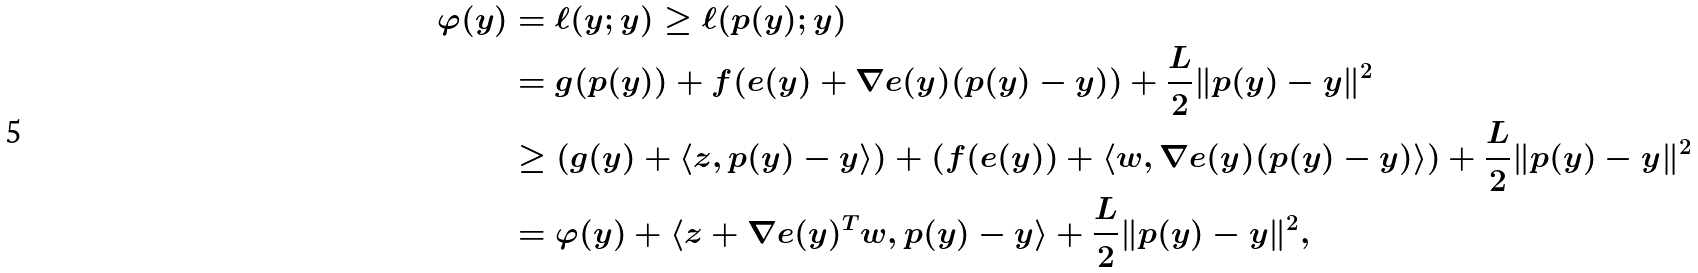Convert formula to latex. <formula><loc_0><loc_0><loc_500><loc_500>\varphi ( y ) & = \ell ( y ; y ) \geq \ell ( p ( y ) ; y ) \\ & = g ( p ( y ) ) + f ( e ( y ) + \nabla e ( y ) ( p ( y ) - y ) ) + \frac { L } { 2 } \| p ( y ) - y \| ^ { 2 } \\ & \geq ( g ( y ) + \langle z , p ( y ) - y \rangle ) + ( f ( e ( y ) ) + \langle w , \nabla e ( y ) ( p ( y ) - y ) \rangle ) + \frac { L } { 2 } \| p ( y ) - y \| ^ { 2 } \\ & = \varphi ( y ) + \langle z + \nabla e ( y ) ^ { T } w , p ( y ) - y \rangle + \frac { L } { 2 } \| p ( y ) - y \| ^ { 2 } ,</formula> 